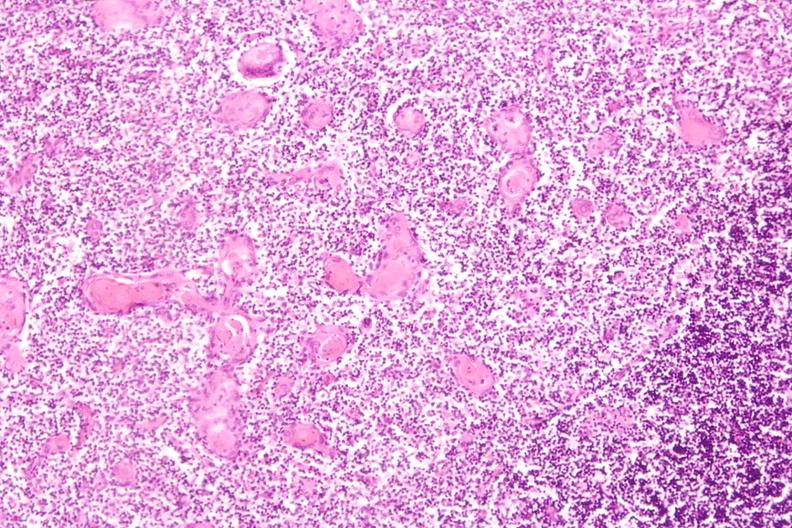how do stress induce involution in baby?
Answer the question using a single word or phrase. Hyaline membrane disease 